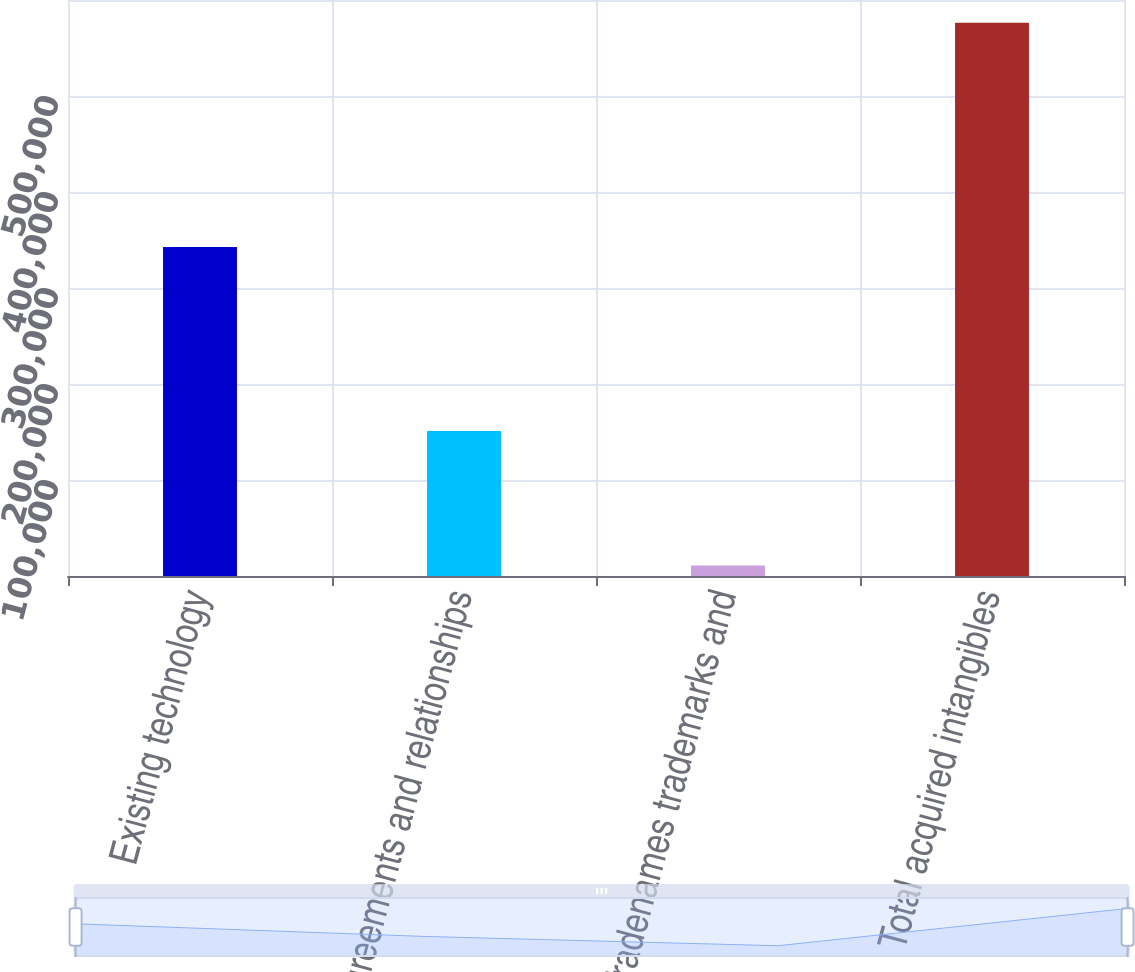<chart> <loc_0><loc_0><loc_500><loc_500><bar_chart><fcel>Existing technology<fcel>Agreements and relationships<fcel>Tradenames trademarks and<fcel>Total acquired intangibles<nl><fcel>342810<fcel>151063<fcel>10918<fcel>576291<nl></chart> 